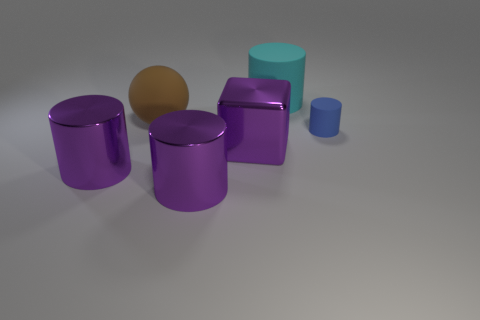Is there any other thing that has the same size as the blue rubber cylinder?
Your answer should be compact. No. Are there more purple cylinders on the right side of the tiny blue cylinder than big purple metallic things left of the block?
Offer a very short reply. No. Is there any other thing of the same color as the small cylinder?
Your answer should be very brief. No. How many things are big gray rubber objects or big shiny cylinders?
Offer a terse response. 2. Do the matte object in front of the ball and the large ball have the same size?
Offer a terse response. No. How many other objects are the same size as the blue rubber cylinder?
Offer a very short reply. 0. Are there any tiny red shiny things?
Ensure brevity in your answer.  No. How big is the shiny object that is in front of the metal object that is left of the big ball?
Your answer should be very brief. Large. There is a cylinder left of the rubber ball; is its color the same as the big matte thing that is on the left side of the cyan cylinder?
Offer a very short reply. No. There is a rubber object that is both in front of the big cyan rubber thing and left of the tiny matte cylinder; what is its color?
Your response must be concise. Brown. 